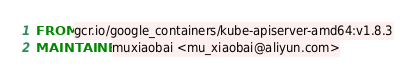<code> <loc_0><loc_0><loc_500><loc_500><_Dockerfile_>FROM gcr.io/google_containers/kube-apiserver-amd64:v1.8.3
MAINTAINER muxiaobai <mu_xiaobai@aliyun.com></code> 